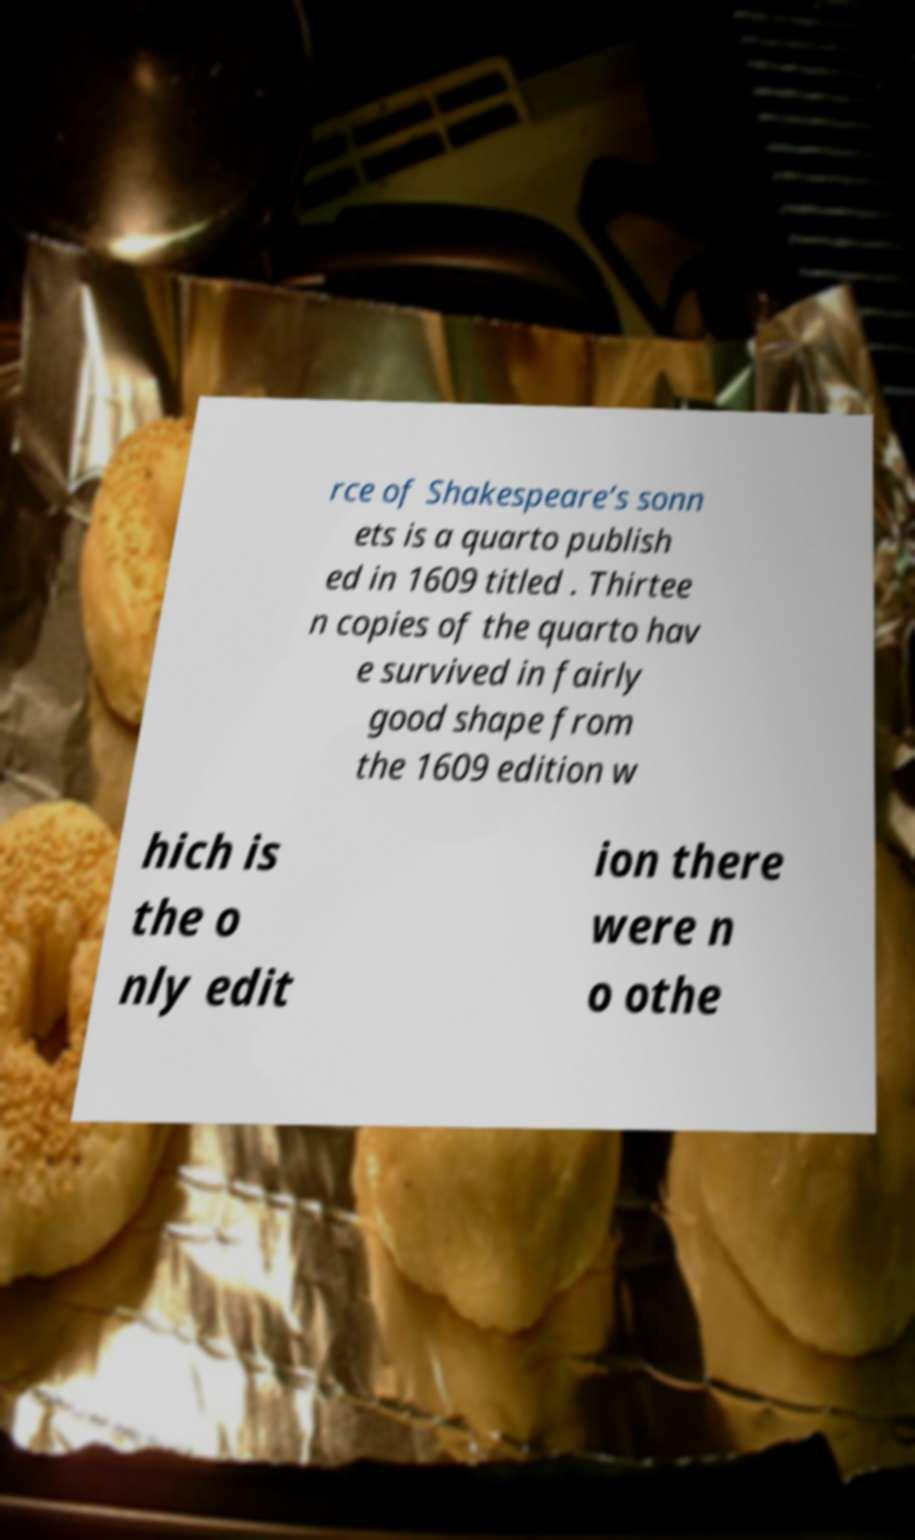Please identify and transcribe the text found in this image. rce of Shakespeare’s sonn ets is a quarto publish ed in 1609 titled . Thirtee n copies of the quarto hav e survived in fairly good shape from the 1609 edition w hich is the o nly edit ion there were n o othe 